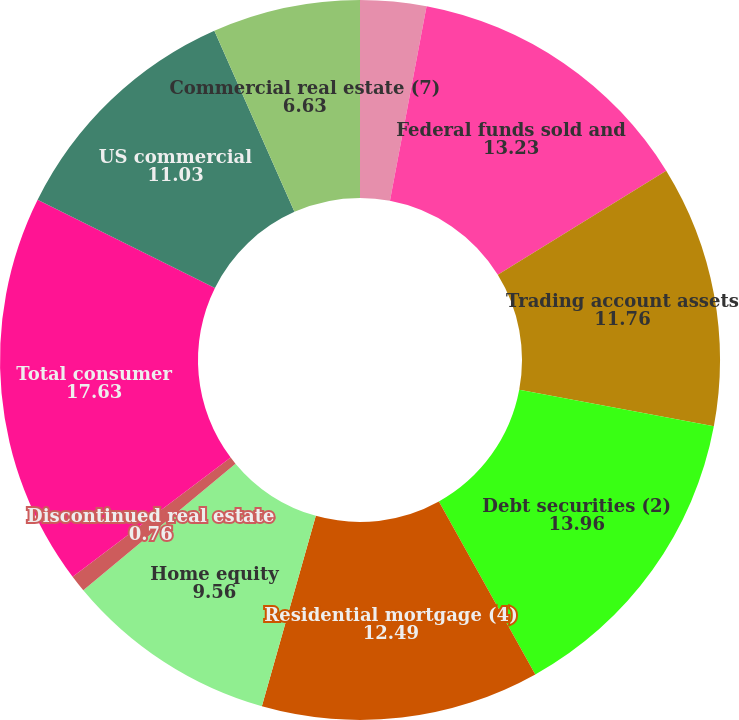Convert chart. <chart><loc_0><loc_0><loc_500><loc_500><pie_chart><fcel>Time deposits placed and other<fcel>Federal funds sold and<fcel>Trading account assets<fcel>Debt securities (2)<fcel>Residential mortgage (4)<fcel>Home equity<fcel>Discontinued real estate<fcel>Total consumer<fcel>US commercial<fcel>Commercial real estate (7)<nl><fcel>2.96%<fcel>13.23%<fcel>11.76%<fcel>13.96%<fcel>12.49%<fcel>9.56%<fcel>0.76%<fcel>17.63%<fcel>11.03%<fcel>6.63%<nl></chart> 